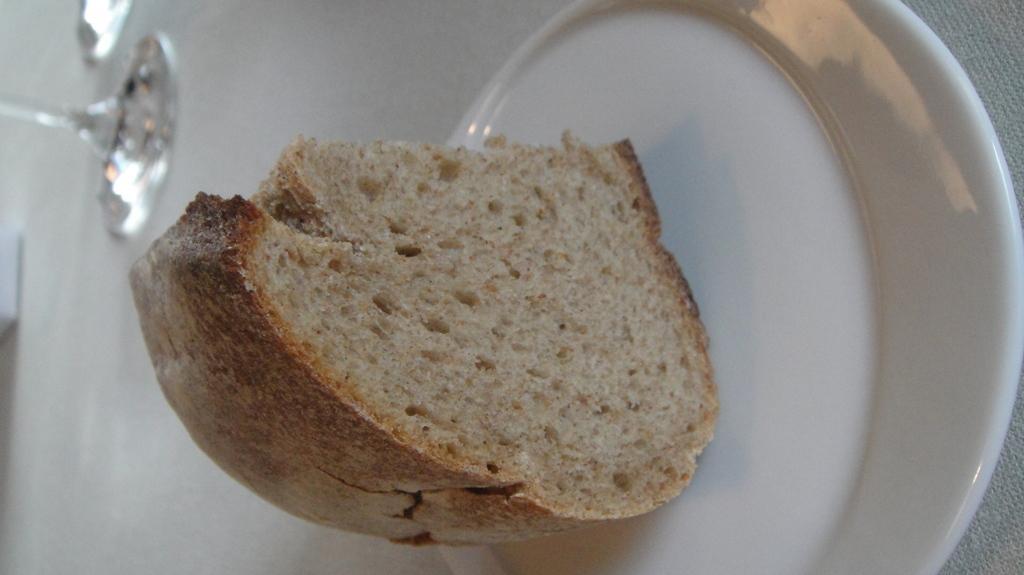Can you describe this image briefly? In this image I can see a white colour plate in the front and on it I can see a piece of a bread. In the background I can see a glass and I can see this image is little bit blurry in the background. 